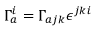Convert formula to latex. <formula><loc_0><loc_0><loc_500><loc_500>\Gamma _ { a } ^ { i } = \Gamma _ { a j k } \epsilon ^ { j k i }</formula> 